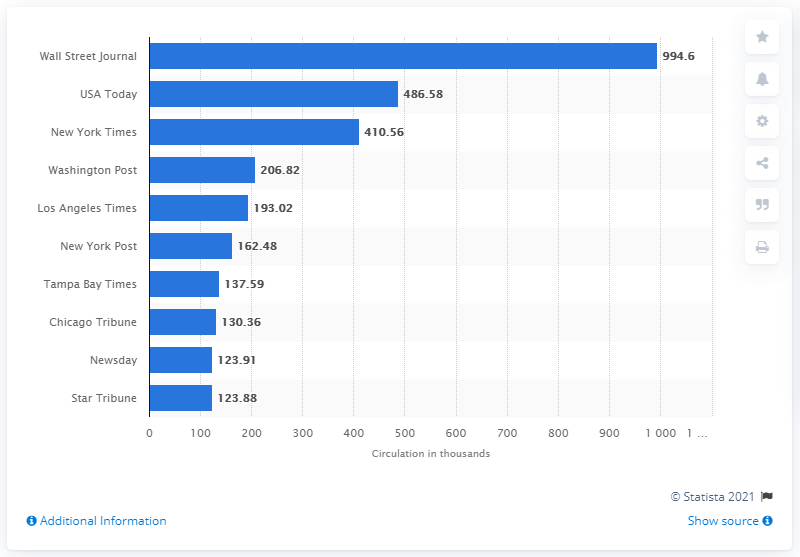Give some essential details in this illustration. The average weekday print circulation of The Wall Street Journal was 994.6 copies. 